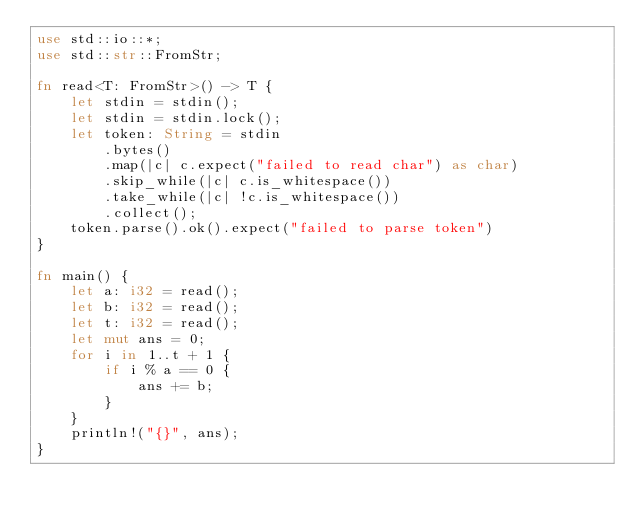<code> <loc_0><loc_0><loc_500><loc_500><_Rust_>use std::io::*;
use std::str::FromStr;

fn read<T: FromStr>() -> T {
    let stdin = stdin();
    let stdin = stdin.lock();
    let token: String = stdin
        .bytes()
        .map(|c| c.expect("failed to read char") as char)
        .skip_while(|c| c.is_whitespace())
        .take_while(|c| !c.is_whitespace())
        .collect();
    token.parse().ok().expect("failed to parse token")
}

fn main() {
    let a: i32 = read();
    let b: i32 = read();
    let t: i32 = read();
    let mut ans = 0;
    for i in 1..t + 1 {
        if i % a == 0 {
            ans += b;
        }
    }
    println!("{}", ans);
}
</code> 